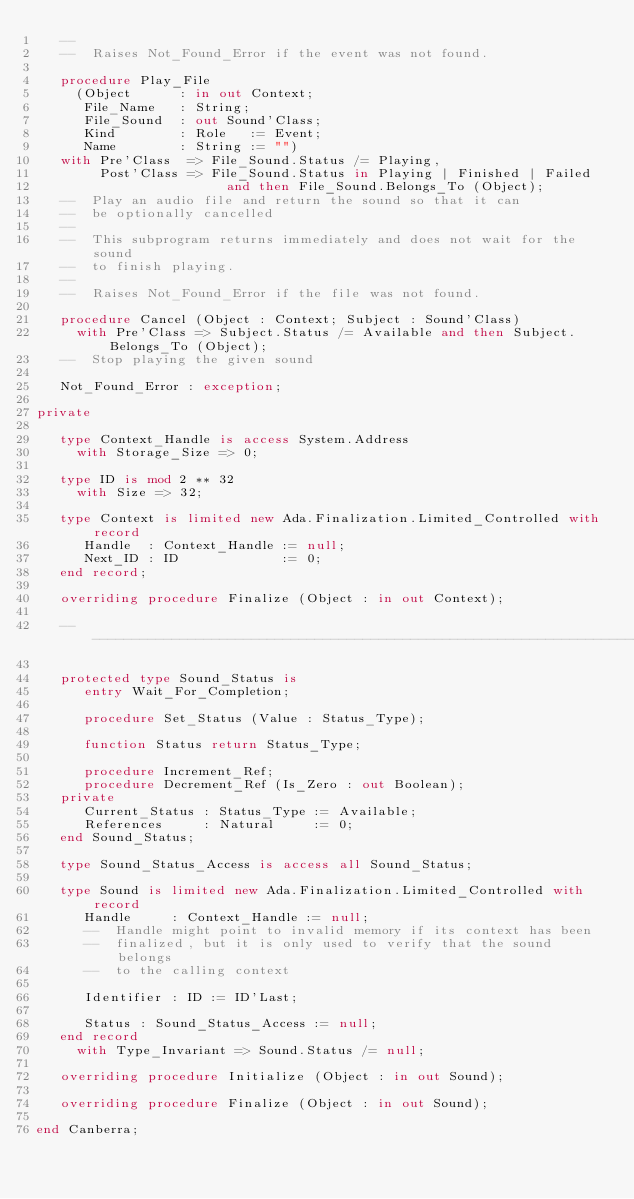Convert code to text. <code><loc_0><loc_0><loc_500><loc_500><_Ada_>   --
   --  Raises Not_Found_Error if the event was not found.

   procedure Play_File
     (Object      : in out Context;
      File_Name   : String;
      File_Sound  : out Sound'Class;
      Kind        : Role   := Event;
      Name        : String := "")
   with Pre'Class  => File_Sound.Status /= Playing,
        Post'Class => File_Sound.Status in Playing | Finished | Failed
                        and then File_Sound.Belongs_To (Object);
   --  Play an audio file and return the sound so that it can
   --  be optionally cancelled
   --
   --  This subprogram returns immediately and does not wait for the sound
   --  to finish playing.
   --
   --  Raises Not_Found_Error if the file was not found.

   procedure Cancel (Object : Context; Subject : Sound'Class)
     with Pre'Class => Subject.Status /= Available and then Subject.Belongs_To (Object);
   --  Stop playing the given sound

   Not_Found_Error : exception;

private

   type Context_Handle is access System.Address
     with Storage_Size => 0;

   type ID is mod 2 ** 32
     with Size => 32;

   type Context is limited new Ada.Finalization.Limited_Controlled with record
      Handle  : Context_Handle := null;
      Next_ID : ID             := 0;
   end record;

   overriding procedure Finalize (Object : in out Context);

   -----------------------------------------------------------------------------

   protected type Sound_Status is
      entry Wait_For_Completion;

      procedure Set_Status (Value : Status_Type);

      function Status return Status_Type;

      procedure Increment_Ref;
      procedure Decrement_Ref (Is_Zero : out Boolean);
   private
      Current_Status : Status_Type := Available;
      References     : Natural     := 0;
   end Sound_Status;

   type Sound_Status_Access is access all Sound_Status;

   type Sound is limited new Ada.Finalization.Limited_Controlled with record
      Handle     : Context_Handle := null;
      --  Handle might point to invalid memory if its context has been
      --  finalized, but it is only used to verify that the sound belongs
      --  to the calling context

      Identifier : ID := ID'Last;

      Status : Sound_Status_Access := null;
   end record
     with Type_Invariant => Sound.Status /= null;

   overriding procedure Initialize (Object : in out Sound);

   overriding procedure Finalize (Object : in out Sound);

end Canberra;
</code> 